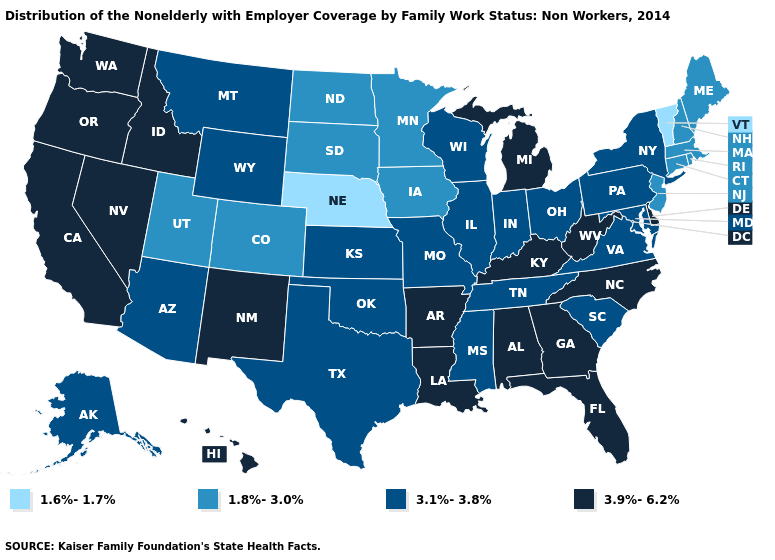What is the value of Illinois?
Write a very short answer. 3.1%-3.8%. What is the value of South Carolina?
Short answer required. 3.1%-3.8%. Does New Hampshire have the highest value in the USA?
Quick response, please. No. Does the first symbol in the legend represent the smallest category?
Quick response, please. Yes. Does the map have missing data?
Keep it brief. No. Name the states that have a value in the range 3.1%-3.8%?
Concise answer only. Alaska, Arizona, Illinois, Indiana, Kansas, Maryland, Mississippi, Missouri, Montana, New York, Ohio, Oklahoma, Pennsylvania, South Carolina, Tennessee, Texas, Virginia, Wisconsin, Wyoming. Name the states that have a value in the range 1.8%-3.0%?
Write a very short answer. Colorado, Connecticut, Iowa, Maine, Massachusetts, Minnesota, New Hampshire, New Jersey, North Dakota, Rhode Island, South Dakota, Utah. Which states hav the highest value in the West?
Give a very brief answer. California, Hawaii, Idaho, Nevada, New Mexico, Oregon, Washington. Name the states that have a value in the range 1.6%-1.7%?
Be succinct. Nebraska, Vermont. Name the states that have a value in the range 3.9%-6.2%?
Concise answer only. Alabama, Arkansas, California, Delaware, Florida, Georgia, Hawaii, Idaho, Kentucky, Louisiana, Michigan, Nevada, New Mexico, North Carolina, Oregon, Washington, West Virginia. What is the value of Alabama?
Quick response, please. 3.9%-6.2%. Is the legend a continuous bar?
Write a very short answer. No. What is the highest value in states that border New Jersey?
Quick response, please. 3.9%-6.2%. Does the first symbol in the legend represent the smallest category?
Concise answer only. Yes. Does Wyoming have the highest value in the West?
Answer briefly. No. 